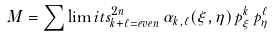Convert formula to latex. <formula><loc_0><loc_0><loc_500><loc_500>M = \sum \lim i t s _ { k + \ell = e v e n } ^ { 2 n } \, \alpha _ { k , \ell } ( \xi , \eta ) \, p ^ { k } _ { \xi } \, p ^ { \ell } _ { \eta }</formula> 